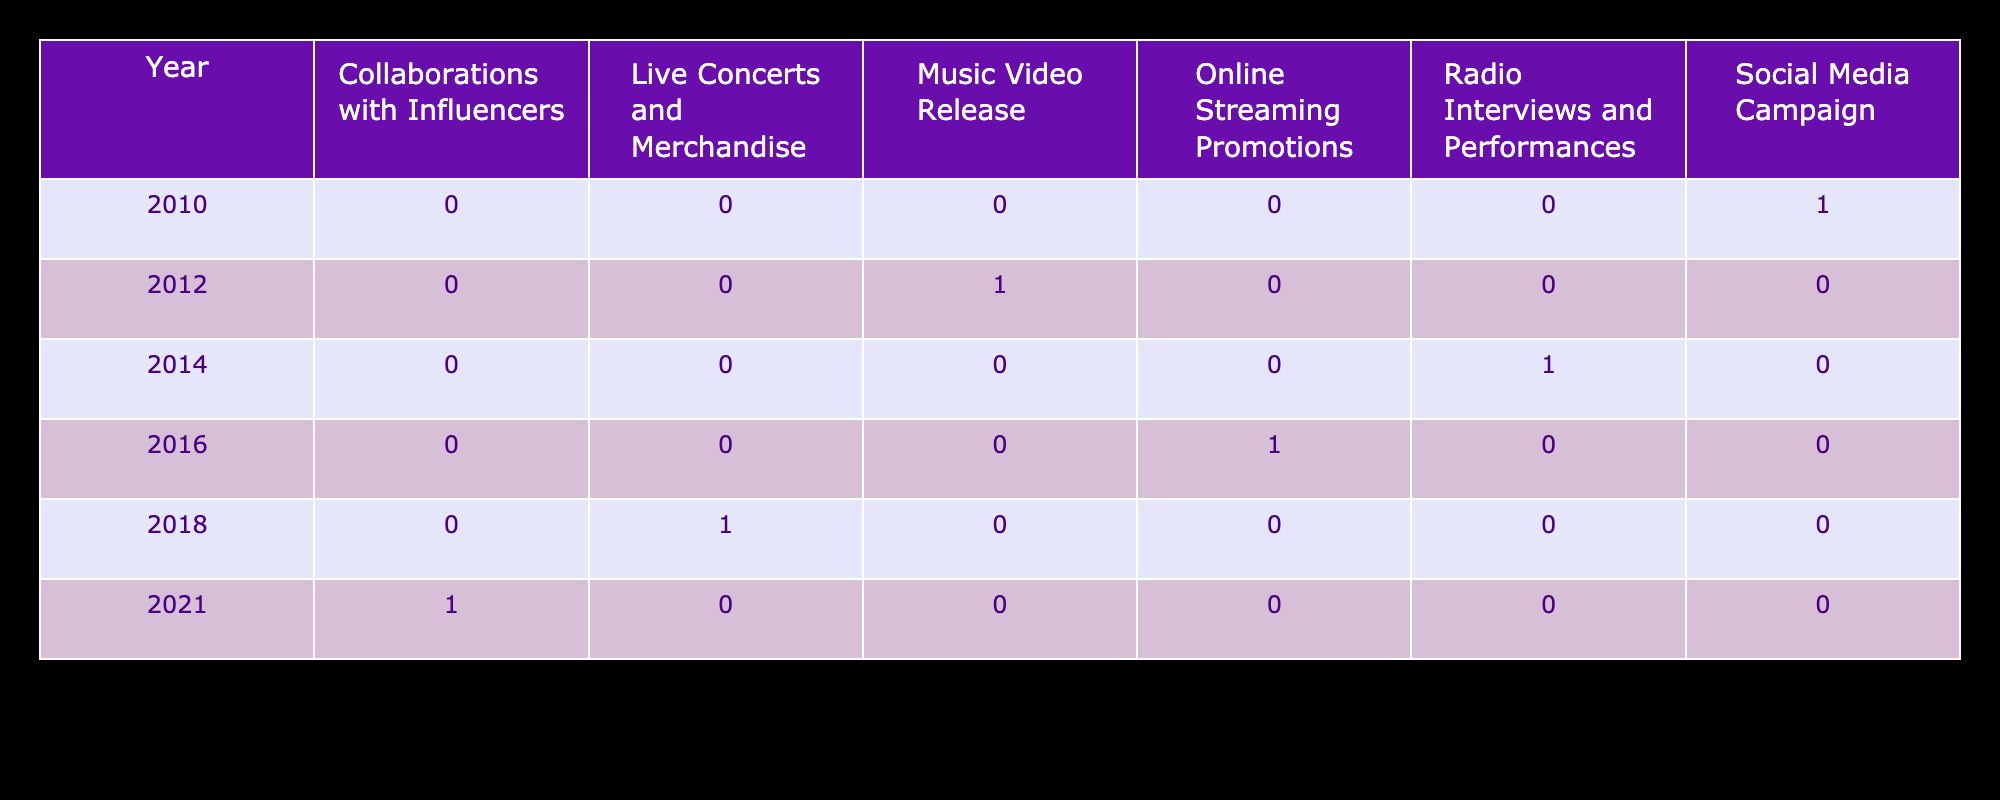What promotional strategy was used for the album "City Nights"? The album "City Nights" was released in 2016. Looking at the table, the promotional strategy listed for this year is "Online Streaming Promotions".
Answer: Online Streaming Promotions How many albums used "Digital Only" as a promotional strategy? By inspecting the table, we see that two albums were released with the "Digital Only" promotional strategy: "Sounds of Tomorrow" in 2012 and "Journey Through Time" in 2021. Therefore, the count is 2.
Answer: 2 Which album was promoted through live concerts and merchandise? The table indicates that the album "Melody in Motion" was released in 2018, and its promotional strategy involved "Live Concerts and Merchandise".
Answer: Melody in Motion What is the total number of albums released in the Pop Rock genre? Looking through the table, we find only one album listed under the Pop Rock genre, which is "Melody in Motion" released in 2018. Thus, the total is 1.
Answer: 1 Did "Back to Roots" have a promotional strategy that included online campaigns? The promotional strategy for "Back to Roots," released in 2014, is "Radio Interviews and Performances," which does not include any online campaigns. Therefore, the answer is No.
Answer: No What is the difference in the number of albums promoted via Social Media Campaign versus Live Concerts and Merchandise? From the table, only one album was promoted via Social Media Campaign ("First Light" in 2010) and one album was promoted via Live Concerts and Merchandise ("Melody in Motion" in 2018). The difference is 1 - 1 = 0.
Answer: 0 Which year had the highest number of unique promotional strategies, and what were they? In the table, we can see that each year has a different promotional strategy. By counting, we find there are no repeating strategies across years. Therefore, every year has exactly 1 unique promotional strategy. The years are 2010, 2012, 2014, 2016, 2018, and 2021, with their respective strategies being: Social Media Campaign, Music Video Release, Radio Interviews and Performances, Online Streaming Promotions, Live Concerts and Merchandise, and Collaborations with Influencers.
Answer: Each year had 1 unique strategy How many albums were released from 2010 to 2018 compared to 2021? From the table, there are 5 albums released from 2010 to 2018 ("First Light", "Sounds of Tomorrow", "Back to Roots", "City Nights", and "Melody in Motion"). In 2021, only one album ("Journey Through Time") was released. Therefore, 5 compared to 1 means the difference is 4 albums.
Answer: 4 Is there any album in the list that used both Digital and CD formats? The table shows that the album "First Light" (2010) and "Melody in Motion" (2018) both utilized the Digital and CD formats for release. Therefore, the answer is Yes, as there are albums that meet this criterion.
Answer: Yes 